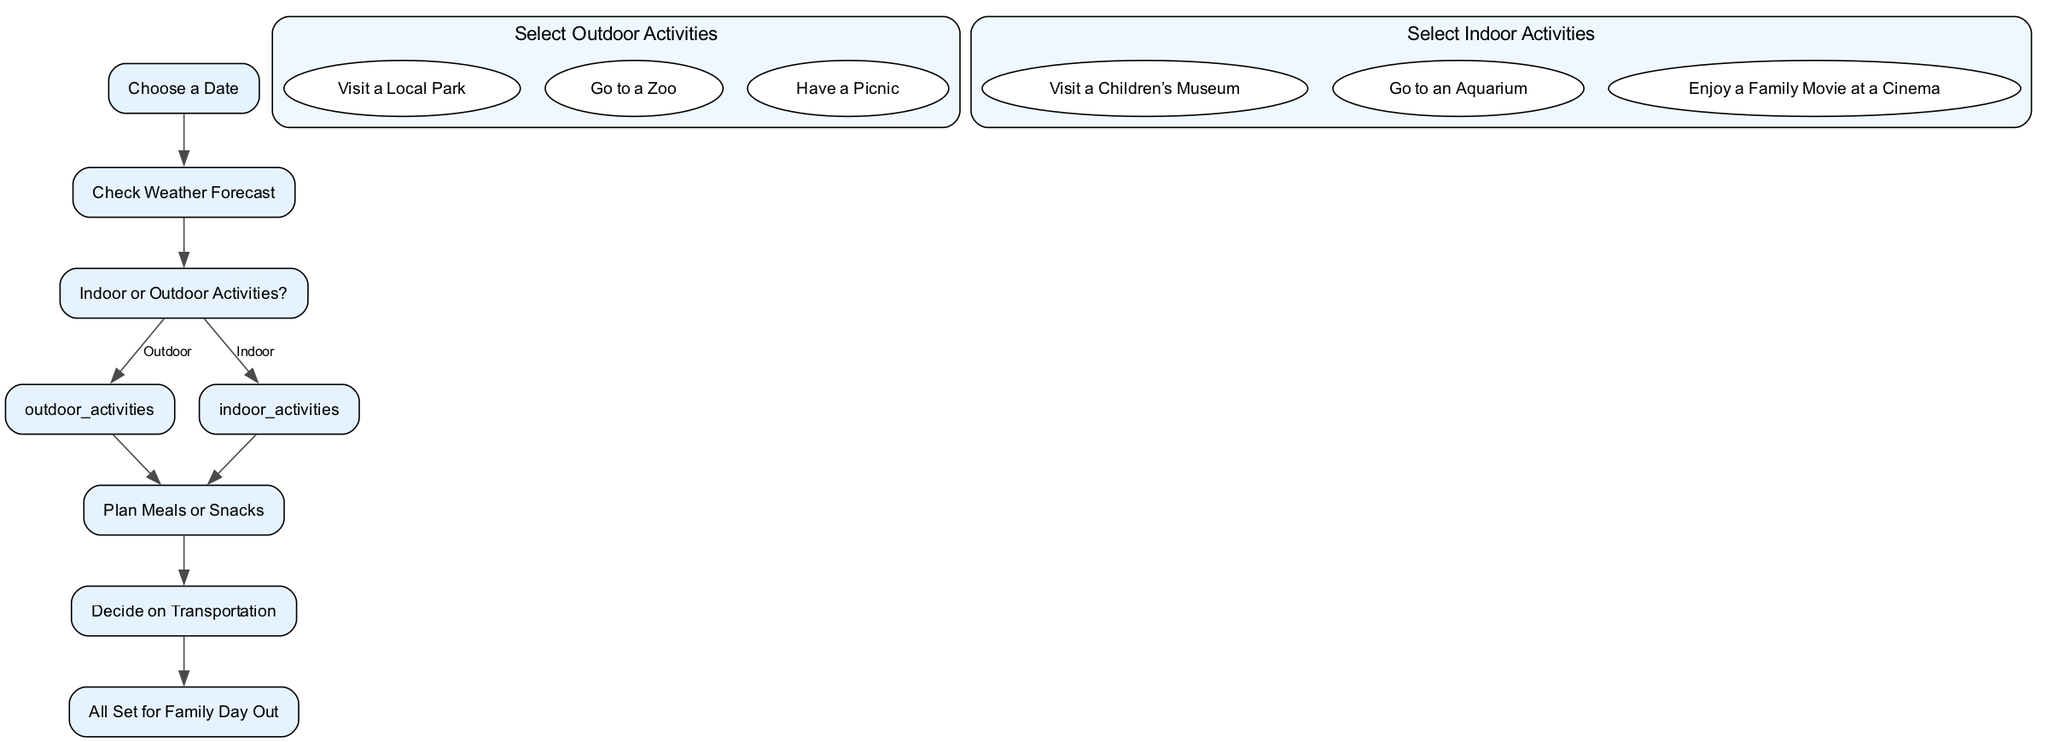What is the first step in planning a family day out? The first step in the flowchart is represented as the node labeled "Choose a Date," which indicates that selecting a date is the initial action required for planning the outing.
Answer: Choose a Date How many options are there for outdoor activities? The "Select Outdoor Activities" node indicates three options: "Visit a Local Park," "Go to a Zoo," and "Have a Picnic," totaling three choices for outdoor activities.
Answer: Three What happens after selecting outdoor activities? Following the "Select Outdoor Activities" node, the diagram directs towards the "Plan Meals or Snacks" node, indicating that meal planning is the subsequent step after outdoor activities are selected.
Answer: Plan Meals or Snacks If the weather is unsuitable for outdoor activities, what is the next step? If the weather forecast suggests unfavorable conditions, the diagram connects from "Check Weather Forecast" to "Indoor or Outdoor Activities?" If indoor is the selected option, it proceeds to "Select Indoor Activities." Thus, the next step would be selecting an indoor activity if outdoor options are off the table.
Answer: Select Indoor Activities What are the options you can choose from for indoor activities? The "Select Indoor Activities" node lists three choices: "Visit a Children’s Museum," "Go to an Aquarium," and "Enjoy a Family Movie at a Cinema." This gives a clear idea of the indoor attractions available for the family outing.
Answer: Visit a Children’s Museum, Go to an Aquarium, Enjoy a Family Movie at a Cinema What is the final step before going on the family day out? The last node before reaching the endpoint is "Decide on Transportation," marking it as the final step required to prepare before heading out for the planned family day.
Answer: Decide on Transportation How many total nodes are present in this flowchart? The flowchart consists of eight distinct elements or nodes: "Choose a Date," "Check Weather Forecast," "Indoor or Outdoor Activities," "Select Outdoor Activities," "Select Indoor Activities," "Plan Meals or Snacks," "Decide on Transportation," and "All Set for Family Day Out."
Answer: Eight What determines whether to select indoor or outdoor activities? The decision between indoor and outdoor activities is dependent on the outcome of checking the weather forecast. If the forecast allows, outdoor activities can be chosen; otherwise, indoor activities will be selected. This decision process hinges on the weather confirmed.
Answer: Check Weather Forecast 